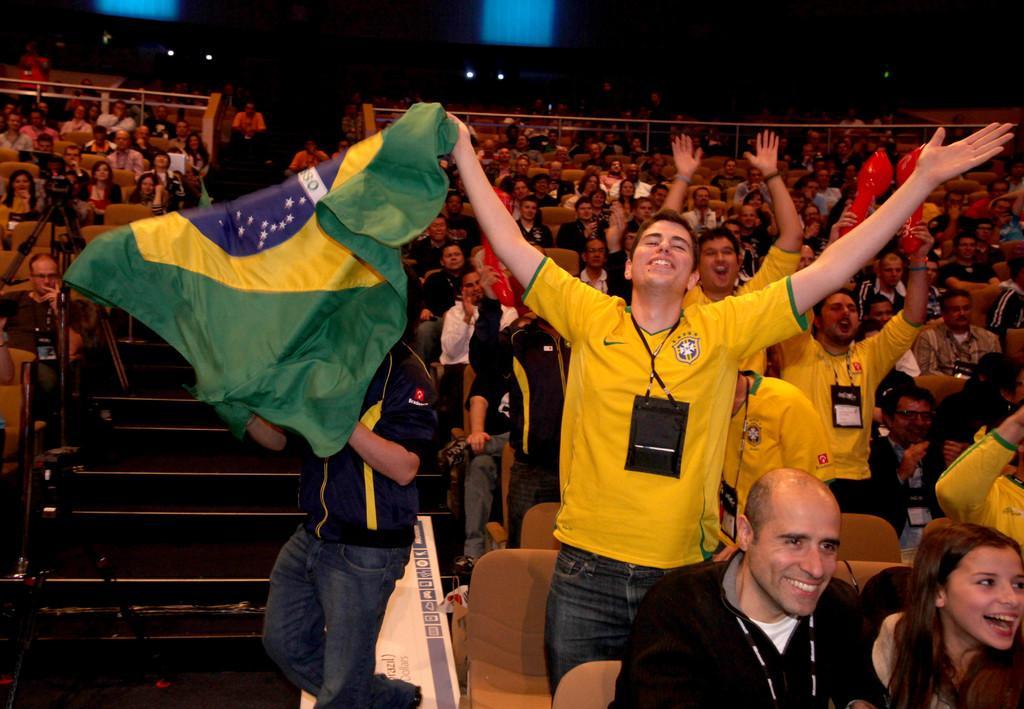Can you describe this image briefly? On the left side of the image we can see stairs and there are many people sitting and some of them are standing. The man in the center is holding a flag in his hand. In the background there are lights. We can see chairs. 